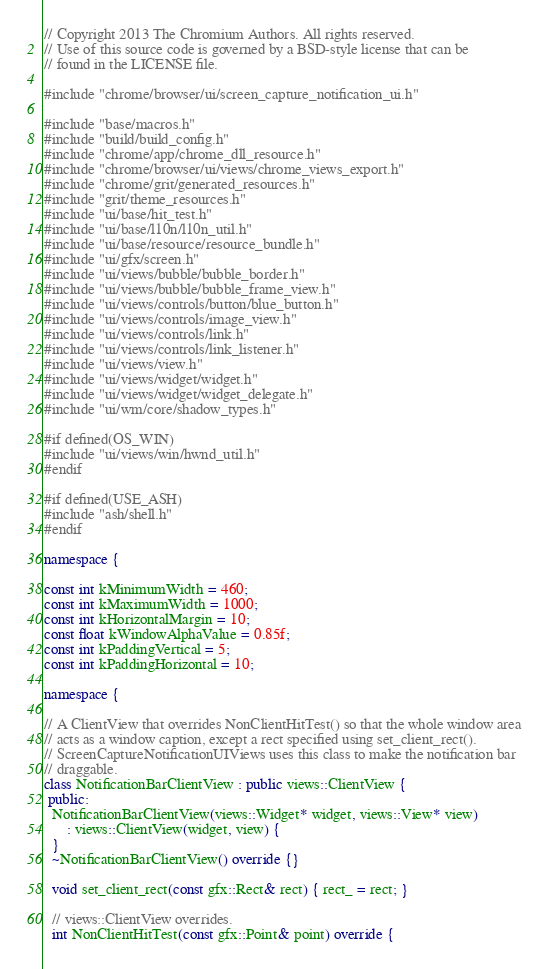Convert code to text. <code><loc_0><loc_0><loc_500><loc_500><_C++_>// Copyright 2013 The Chromium Authors. All rights reserved.
// Use of this source code is governed by a BSD-style license that can be
// found in the LICENSE file.

#include "chrome/browser/ui/screen_capture_notification_ui.h"

#include "base/macros.h"
#include "build/build_config.h"
#include "chrome/app/chrome_dll_resource.h"
#include "chrome/browser/ui/views/chrome_views_export.h"
#include "chrome/grit/generated_resources.h"
#include "grit/theme_resources.h"
#include "ui/base/hit_test.h"
#include "ui/base/l10n/l10n_util.h"
#include "ui/base/resource/resource_bundle.h"
#include "ui/gfx/screen.h"
#include "ui/views/bubble/bubble_border.h"
#include "ui/views/bubble/bubble_frame_view.h"
#include "ui/views/controls/button/blue_button.h"
#include "ui/views/controls/image_view.h"
#include "ui/views/controls/link.h"
#include "ui/views/controls/link_listener.h"
#include "ui/views/view.h"
#include "ui/views/widget/widget.h"
#include "ui/views/widget/widget_delegate.h"
#include "ui/wm/core/shadow_types.h"

#if defined(OS_WIN)
#include "ui/views/win/hwnd_util.h"
#endif

#if defined(USE_ASH)
#include "ash/shell.h"
#endif

namespace {

const int kMinimumWidth = 460;
const int kMaximumWidth = 1000;
const int kHorizontalMargin = 10;
const float kWindowAlphaValue = 0.85f;
const int kPaddingVertical = 5;
const int kPaddingHorizontal = 10;

namespace {

// A ClientView that overrides NonClientHitTest() so that the whole window area
// acts as a window caption, except a rect specified using set_client_rect().
// ScreenCaptureNotificationUIViews uses this class to make the notification bar
// draggable.
class NotificationBarClientView : public views::ClientView {
 public:
  NotificationBarClientView(views::Widget* widget, views::View* view)
      : views::ClientView(widget, view) {
  }
  ~NotificationBarClientView() override {}

  void set_client_rect(const gfx::Rect& rect) { rect_ = rect; }

  // views::ClientView overrides.
  int NonClientHitTest(const gfx::Point& point) override {</code> 